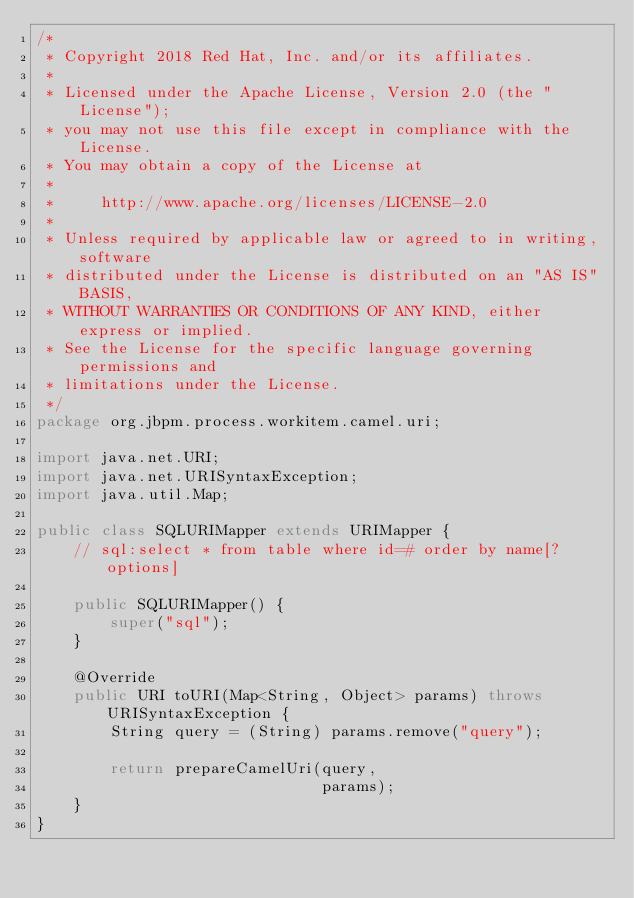Convert code to text. <code><loc_0><loc_0><loc_500><loc_500><_Java_>/*
 * Copyright 2018 Red Hat, Inc. and/or its affiliates.
 *
 * Licensed under the Apache License, Version 2.0 (the "License");
 * you may not use this file except in compliance with the License.
 * You may obtain a copy of the License at
 *
 *     http://www.apache.org/licenses/LICENSE-2.0
 *
 * Unless required by applicable law or agreed to in writing, software
 * distributed under the License is distributed on an "AS IS" BASIS,
 * WITHOUT WARRANTIES OR CONDITIONS OF ANY KIND, either express or implied.
 * See the License for the specific language governing permissions and
 * limitations under the License.
 */
package org.jbpm.process.workitem.camel.uri;

import java.net.URI;
import java.net.URISyntaxException;
import java.util.Map;

public class SQLURIMapper extends URIMapper {
    // sql:select * from table where id=# order by name[?options]

    public SQLURIMapper() {
        super("sql");
    }

    @Override
    public URI toURI(Map<String, Object> params) throws URISyntaxException {
        String query = (String) params.remove("query");

        return prepareCamelUri(query,
                               params);
    }
}
</code> 